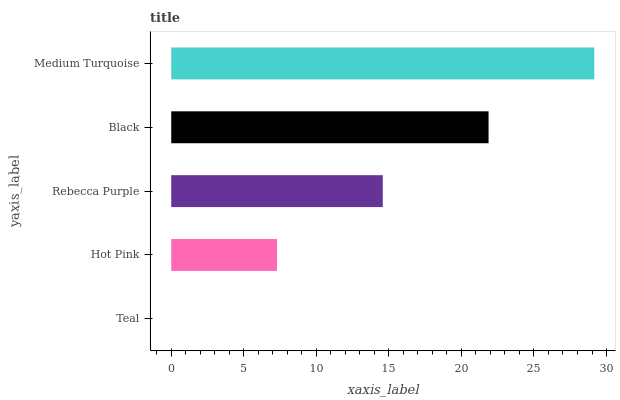Is Teal the minimum?
Answer yes or no. Yes. Is Medium Turquoise the maximum?
Answer yes or no. Yes. Is Hot Pink the minimum?
Answer yes or no. No. Is Hot Pink the maximum?
Answer yes or no. No. Is Hot Pink greater than Teal?
Answer yes or no. Yes. Is Teal less than Hot Pink?
Answer yes or no. Yes. Is Teal greater than Hot Pink?
Answer yes or no. No. Is Hot Pink less than Teal?
Answer yes or no. No. Is Rebecca Purple the high median?
Answer yes or no. Yes. Is Rebecca Purple the low median?
Answer yes or no. Yes. Is Medium Turquoise the high median?
Answer yes or no. No. Is Teal the low median?
Answer yes or no. No. 